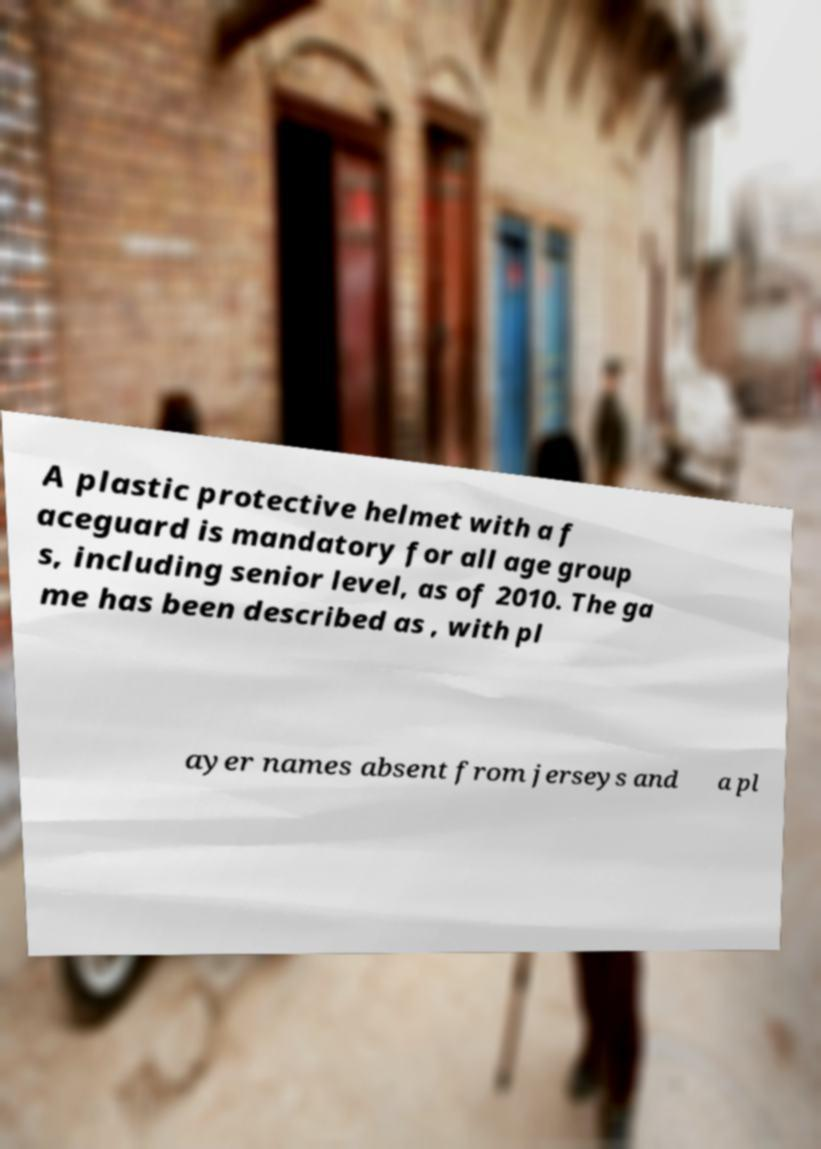Please identify and transcribe the text found in this image. A plastic protective helmet with a f aceguard is mandatory for all age group s, including senior level, as of 2010. The ga me has been described as , with pl ayer names absent from jerseys and a pl 